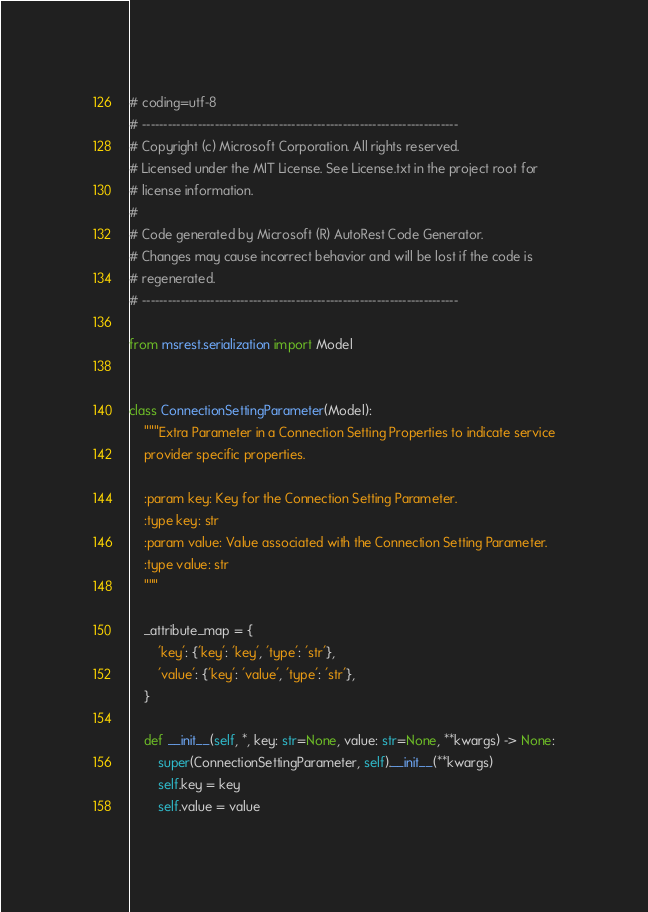<code> <loc_0><loc_0><loc_500><loc_500><_Python_># coding=utf-8
# --------------------------------------------------------------------------
# Copyright (c) Microsoft Corporation. All rights reserved.
# Licensed under the MIT License. See License.txt in the project root for
# license information.
#
# Code generated by Microsoft (R) AutoRest Code Generator.
# Changes may cause incorrect behavior and will be lost if the code is
# regenerated.
# --------------------------------------------------------------------------

from msrest.serialization import Model


class ConnectionSettingParameter(Model):
    """Extra Parameter in a Connection Setting Properties to indicate service
    provider specific properties.

    :param key: Key for the Connection Setting Parameter.
    :type key: str
    :param value: Value associated with the Connection Setting Parameter.
    :type value: str
    """

    _attribute_map = {
        'key': {'key': 'key', 'type': 'str'},
        'value': {'key': 'value', 'type': 'str'},
    }

    def __init__(self, *, key: str=None, value: str=None, **kwargs) -> None:
        super(ConnectionSettingParameter, self).__init__(**kwargs)
        self.key = key
        self.value = value
</code> 